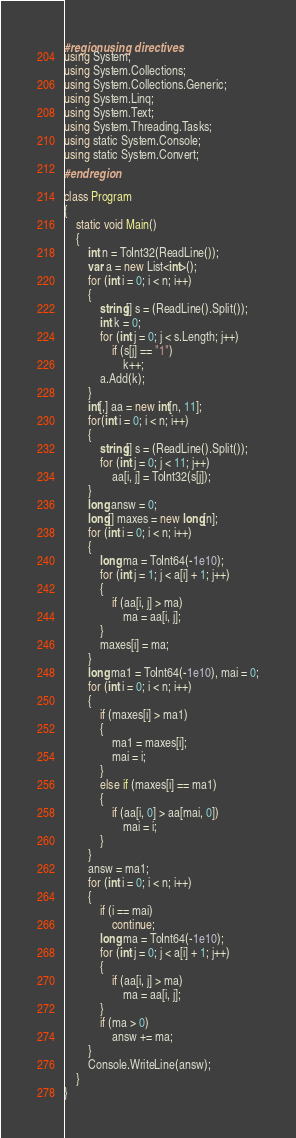<code> <loc_0><loc_0><loc_500><loc_500><_C#_>#region using directives
using System;
using System.Collections;
using System.Collections.Generic;
using System.Linq;
using System.Text;
using System.Threading.Tasks;
using static System.Console;
using static System.Convert;
#endregion

class Program
{
    static void Main()
    {
        int n = ToInt32(ReadLine());
        var a = new List<int>();
        for (int i = 0; i < n; i++)
        {
            string[] s = (ReadLine().Split());
            int k = 0;
            for (int j = 0; j < s.Length; j++)
                if (s[j] == "1")
                    k++;
            a.Add(k);
        }
        int[,] aa = new int[n, 11];
        for(int i = 0; i < n; i++)
        {
            string[] s = (ReadLine().Split());
            for (int j = 0; j < 11; j++)
                aa[i, j] = ToInt32(s[j]);
        }
        long answ = 0;
        long[] maxes = new long[n];
        for (int i = 0; i < n; i++)
        {
            long ma = ToInt64(-1e10);
            for (int j = 1; j < a[i] + 1; j++)
            {
                if (aa[i, j] > ma)
                    ma = aa[i, j];
            }
            maxes[i] = ma;
        }
        long ma1 = ToInt64(-1e10), mai = 0;
        for (int i = 0; i < n; i++)
        {
            if (maxes[i] > ma1)
            {
                ma1 = maxes[i];
                mai = i;
            }
            else if (maxes[i] == ma1)
            {
                if (aa[i, 0] > aa[mai, 0])
                    mai = i;
            }
        }
        answ = ma1;
        for (int i = 0; i < n; i++)
        {
            if (i == mai)
                continue;
            long ma = ToInt64(-1e10);
            for (int j = 0; j < a[i] + 1; j++)
            {
                if (aa[i, j] > ma)
                    ma = aa[i, j];
            }
            if (ma > 0)
                answ += ma;
        }
        Console.WriteLine(answ);
    }
}
</code> 